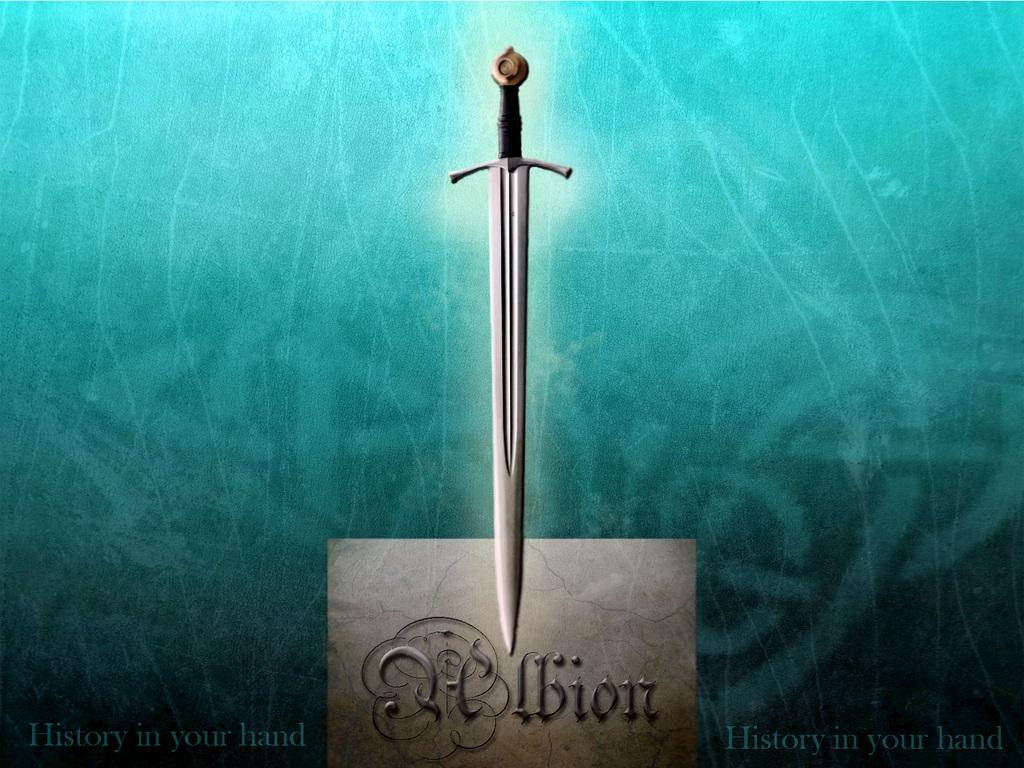What type of image is being described? The image is an animated picture. What object can be seen in the image? There is a sword depicted in the image. Does the sword have a name? Yes, the sword has a name. Is there any text present in the image? Yes, there is some text at the bottom of the image. How many bikes are parked next to the sword in the image? There are no bikes present in the image; it only features a sword and some text. Can you recite the verse written at the bottom of the image? There is no verse present in the image; only some text is mentioned. 